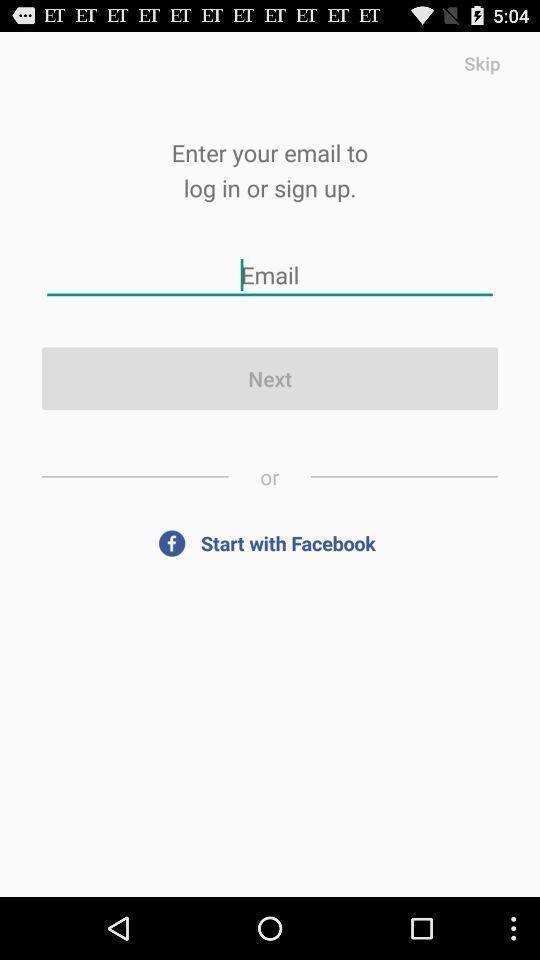Describe the visual elements of this screenshot. Sign up page of a time table app. 